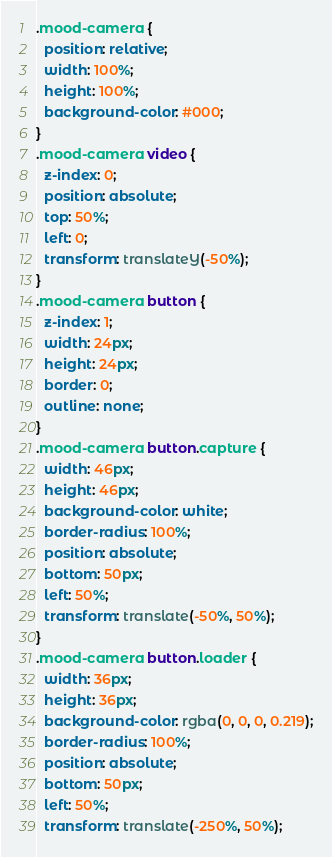<code> <loc_0><loc_0><loc_500><loc_500><_CSS_>.mood-camera {
  position: relative;
  width: 100%;
  height: 100%;
  background-color: #000;
}
.mood-camera video {
  z-index: 0;
  position: absolute;
  top: 50%;
  left: 0;
  transform: translateY(-50%);
}
.mood-camera button {
  z-index: 1;
  width: 24px;
  height: 24px;
  border: 0;
  outline: none;
}
.mood-camera button.capture {
  width: 46px;
  height: 46px;
  background-color: white;
  border-radius: 100%;
  position: absolute;
  bottom: 50px;
  left: 50%;
  transform: translate(-50%, 50%);
}
.mood-camera button.loader {
  width: 36px;
  height: 36px;
  background-color: rgba(0, 0, 0, 0.219);
  border-radius: 100%;
  position: absolute;
  bottom: 50px;
  left: 50%;
  transform: translate(-250%, 50%);</code> 